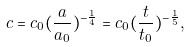Convert formula to latex. <formula><loc_0><loc_0><loc_500><loc_500>c = c _ { 0 } ( \frac { a } { a _ { 0 } } ) ^ { - \frac { 1 } { 4 } } = c _ { 0 } ( \frac { t } { t _ { 0 } } ) ^ { - \frac { 1 } { 5 } } ,</formula> 